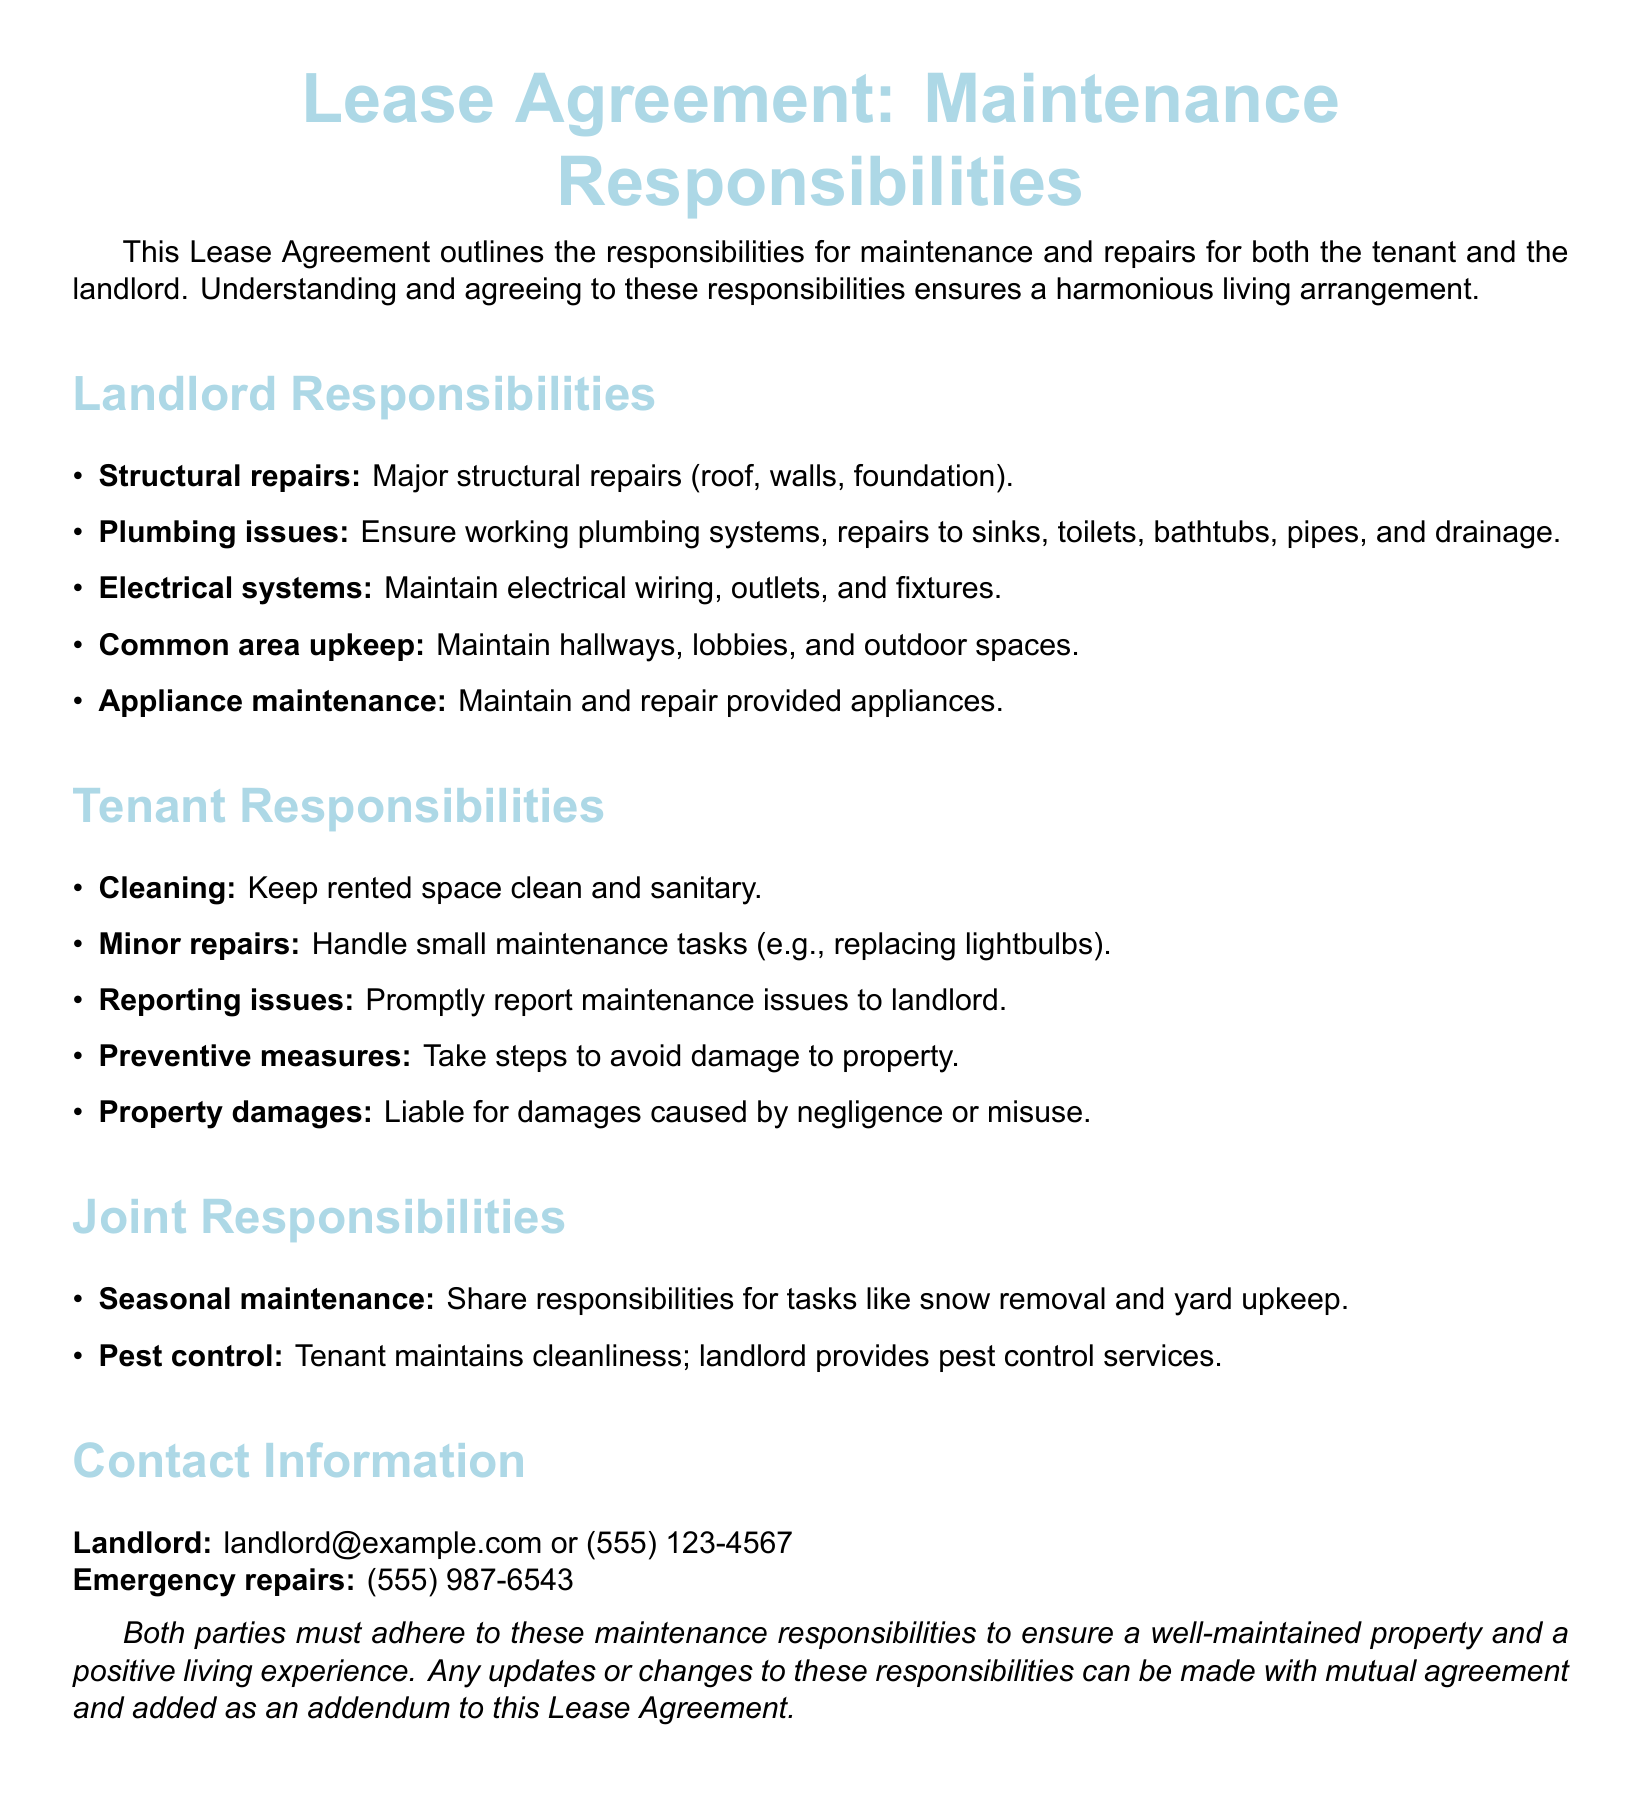what are the landlord's responsibilities? The section titled "Landlord Responsibilities" outlines the duties concerning structural repairs, plumbing issues, electrical systems, common area upkeep, and appliance maintenance.
Answer: Major structural repairs, plumbing issues, electrical systems, common area upkeep, appliance maintenance what must a tenant do regarding minor repairs? The "Tenant Responsibilities" section specifies that tenants are responsible for handling small maintenance tasks, like replacing lightbulbs.
Answer: Handle small maintenance tasks who is responsible for seasonal maintenance? The document indicates that seasonal maintenance responsibilities are a joint effort between the landlord and tenant.
Answer: Joint responsibilities what should a tenant do if they encounter a maintenance issue? The tenant responsibilities highlight that they must promptly report maintenance issues to the landlord.
Answer: Promptly report maintenance issues what types of repairs does the landlord handle? The list of landlord responsibilities includes specific phrases like "major structural repairs," indicating the types they handle.
Answer: Major structural repairs how should cleanliness be maintained? The responsibilities indicate that tenants must keep the rented space clean and sanitary as part of their duties.
Answer: Keep rented space clean and sanitary what contact information is provided for emergencies? The document states that there's a specific number for emergency repairs: (555) 987-6543.
Answer: (555) 987-6543 what happens in the event of negligence? It’s stated in tenant responsibilities that tenants are liable for damages caused by negligence or misuse.
Answer: Liable for damages caused by negligence who provides pest control services? The joint responsibilities section indicates that the landlord provides pest control services.
Answer: Landlord how is the maintenance agreement concluded? The conclusion expresses that updates or changes can be made with mutual agreement to add to the lease agreement.
Answer: Mutual agreement 